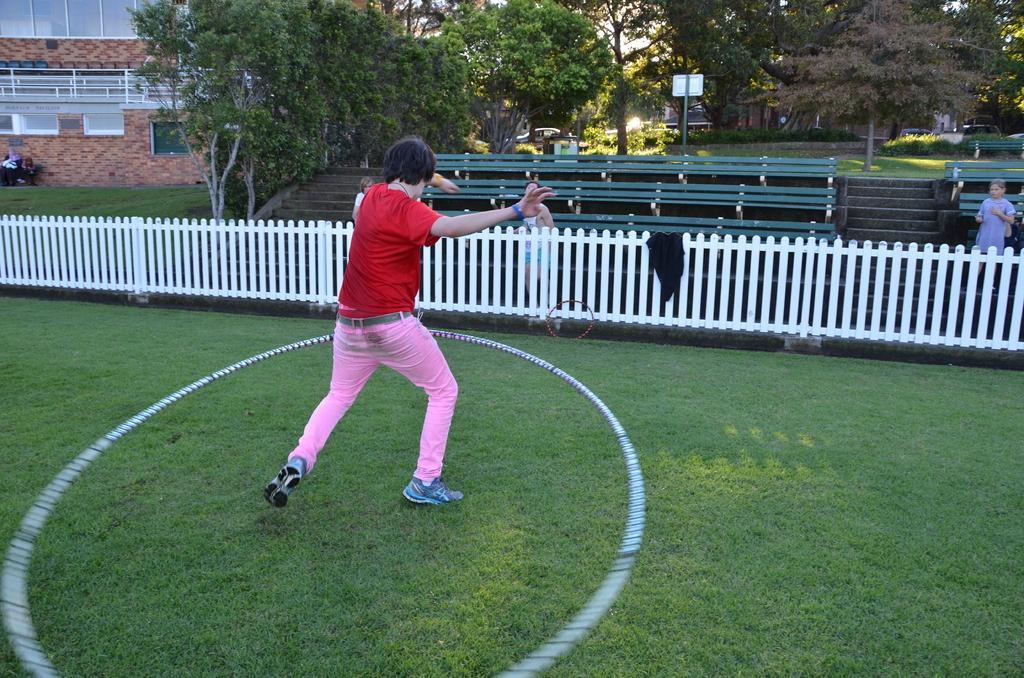In one or two sentences, can you explain what this image depicts? In the picture I can see a person wearing red T-shirt, pink pant and shoes is standing on the grass. Here we can see the white color fence, two persons standing here, we can see wooden benches, the wall, trees, board and house in the background. 